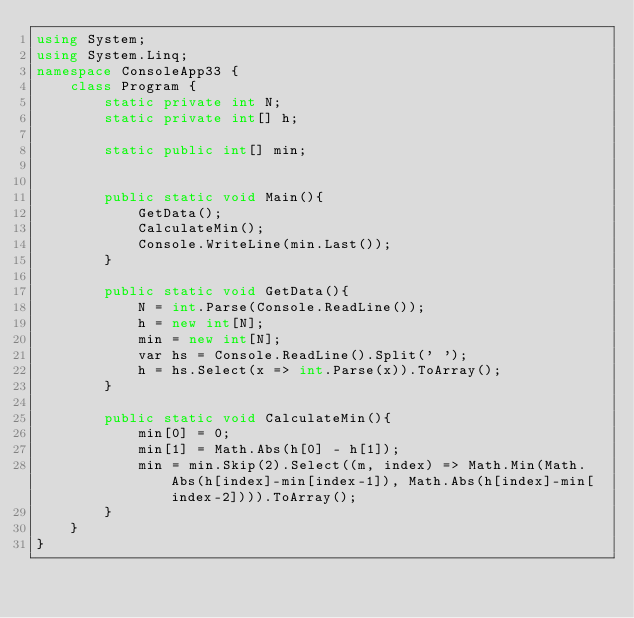<code> <loc_0><loc_0><loc_500><loc_500><_C#_>using System;
using System.Linq;
namespace ConsoleApp33 {
    class Program {
        static private int N;
        static private int[] h;
        
        static public int[] min;
        
        
        public static void Main(){
            GetData();
            CalculateMin();
            Console.WriteLine(min.Last());
        }
        
        public static void GetData(){
            N = int.Parse(Console.ReadLine());
            h = new int[N];
          	min = new int[N];
            var hs = Console.ReadLine().Split(' ');
            h = hs.Select(x => int.Parse(x)).ToArray();
        }
        
        public static void CalculateMin(){
            min[0] = 0;
            min[1] = Math.Abs(h[0] - h[1]);
          	min = min.Skip(2).Select((m, index) => Math.Min(Math.Abs(h[index]-min[index-1]), Math.Abs(h[index]-min[index-2]))).ToArray();
        }
    }
}</code> 